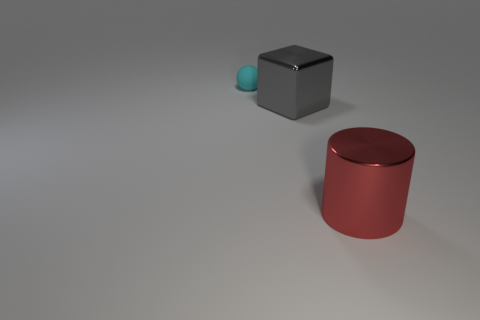What does the positioning of the objects suggest to you? The arrangement of the objects in the space seems deliberate and spaced out. This creates a minimalistic composition that may invoke a sense of order and tranquility. The distances between objects could indicate an intent to highlight their individual features and colors. 